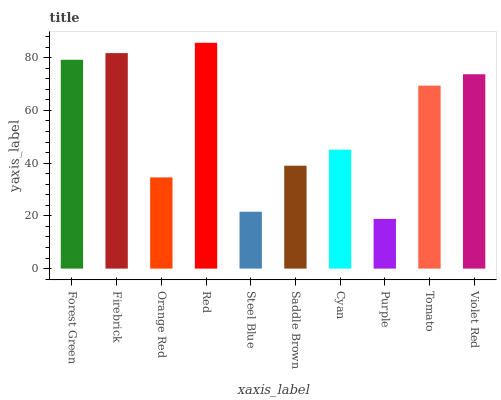Is Purple the minimum?
Answer yes or no. Yes. Is Red the maximum?
Answer yes or no. Yes. Is Firebrick the minimum?
Answer yes or no. No. Is Firebrick the maximum?
Answer yes or no. No. Is Firebrick greater than Forest Green?
Answer yes or no. Yes. Is Forest Green less than Firebrick?
Answer yes or no. Yes. Is Forest Green greater than Firebrick?
Answer yes or no. No. Is Firebrick less than Forest Green?
Answer yes or no. No. Is Tomato the high median?
Answer yes or no. Yes. Is Cyan the low median?
Answer yes or no. Yes. Is Saddle Brown the high median?
Answer yes or no. No. Is Orange Red the low median?
Answer yes or no. No. 